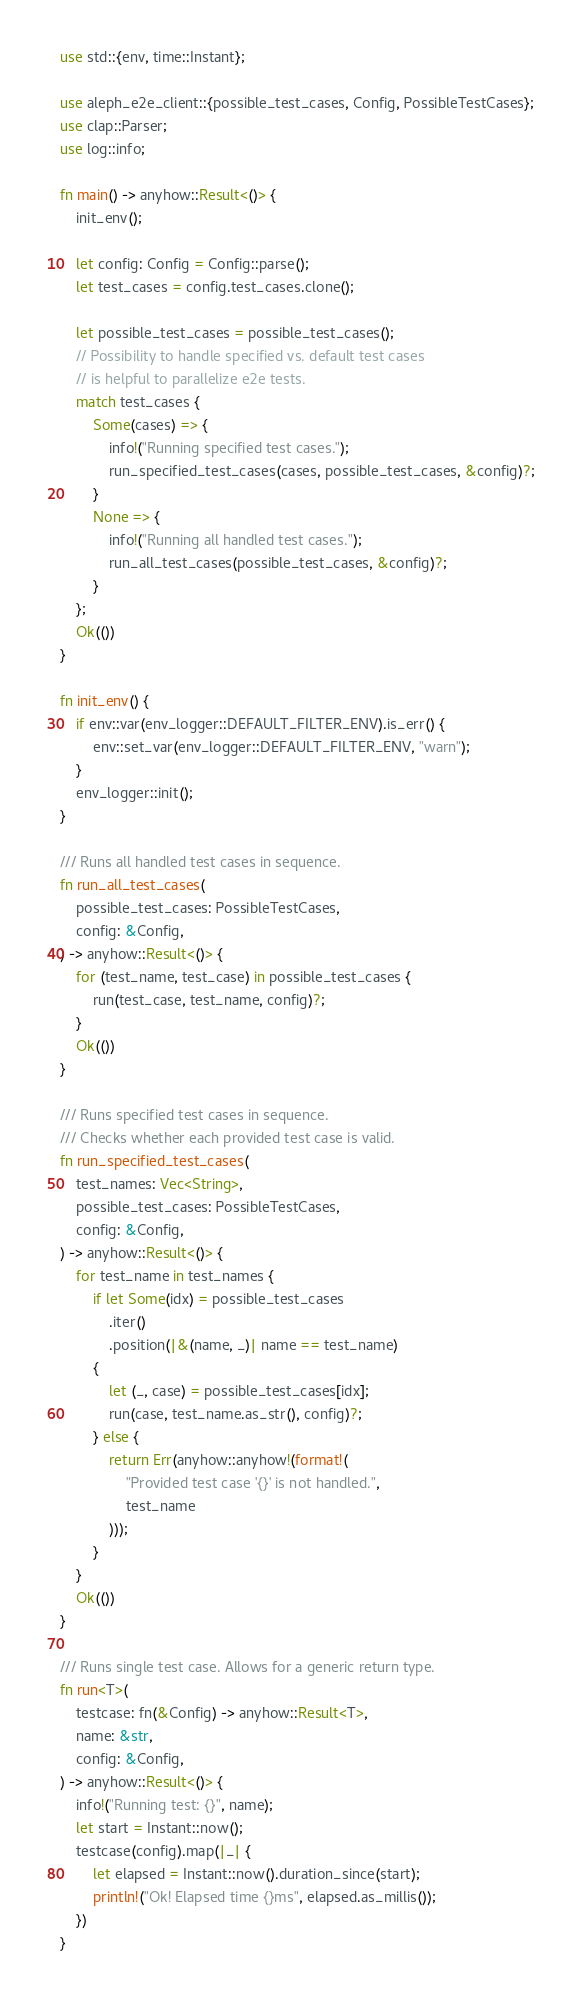<code> <loc_0><loc_0><loc_500><loc_500><_Rust_>use std::{env, time::Instant};

use aleph_e2e_client::{possible_test_cases, Config, PossibleTestCases};
use clap::Parser;
use log::info;

fn main() -> anyhow::Result<()> {
    init_env();

    let config: Config = Config::parse();
    let test_cases = config.test_cases.clone();

    let possible_test_cases = possible_test_cases();
    // Possibility to handle specified vs. default test cases
    // is helpful to parallelize e2e tests.
    match test_cases {
        Some(cases) => {
            info!("Running specified test cases.");
            run_specified_test_cases(cases, possible_test_cases, &config)?;
        }
        None => {
            info!("Running all handled test cases.");
            run_all_test_cases(possible_test_cases, &config)?;
        }
    };
    Ok(())
}

fn init_env() {
    if env::var(env_logger::DEFAULT_FILTER_ENV).is_err() {
        env::set_var(env_logger::DEFAULT_FILTER_ENV, "warn");
    }
    env_logger::init();
}

/// Runs all handled test cases in sequence.
fn run_all_test_cases(
    possible_test_cases: PossibleTestCases,
    config: &Config,
) -> anyhow::Result<()> {
    for (test_name, test_case) in possible_test_cases {
        run(test_case, test_name, config)?;
    }
    Ok(())
}

/// Runs specified test cases in sequence.
/// Checks whether each provided test case is valid.
fn run_specified_test_cases(
    test_names: Vec<String>,
    possible_test_cases: PossibleTestCases,
    config: &Config,
) -> anyhow::Result<()> {
    for test_name in test_names {
        if let Some(idx) = possible_test_cases
            .iter()
            .position(|&(name, _)| name == test_name)
        {
            let (_, case) = possible_test_cases[idx];
            run(case, test_name.as_str(), config)?;
        } else {
            return Err(anyhow::anyhow!(format!(
                "Provided test case '{}' is not handled.",
                test_name
            )));
        }
    }
    Ok(())
}

/// Runs single test case. Allows for a generic return type.
fn run<T>(
    testcase: fn(&Config) -> anyhow::Result<T>,
    name: &str,
    config: &Config,
) -> anyhow::Result<()> {
    info!("Running test: {}", name);
    let start = Instant::now();
    testcase(config).map(|_| {
        let elapsed = Instant::now().duration_since(start);
        println!("Ok! Elapsed time {}ms", elapsed.as_millis());
    })
}
</code> 